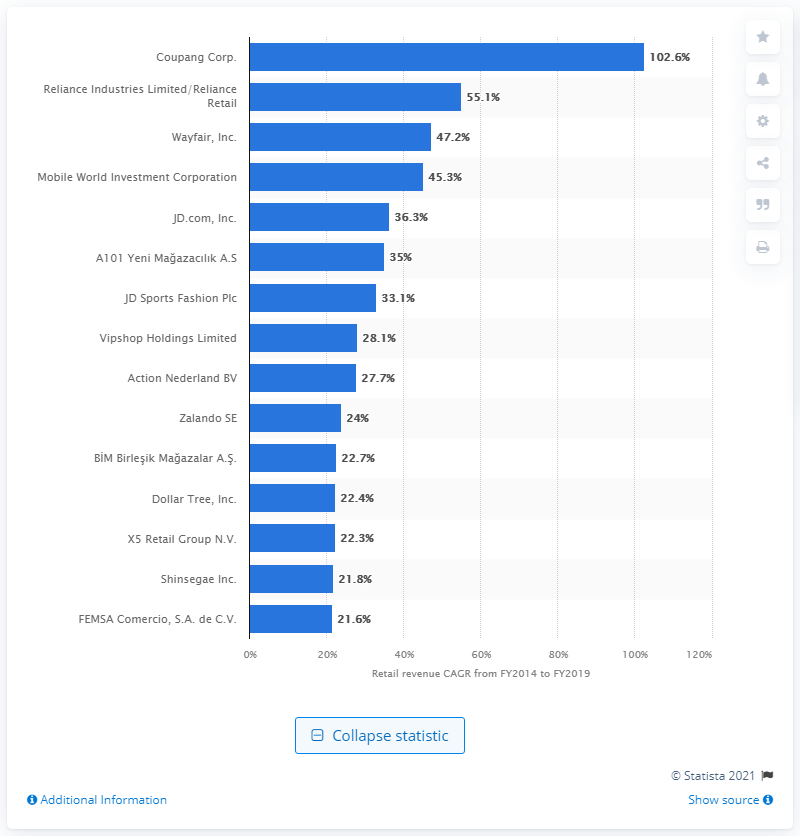Outline some significant characteristics in this image. During the period of 2014 to 2019, Reliance Industries Limited/Reliance Retail was the second-fastest-growing retailer in the world. 